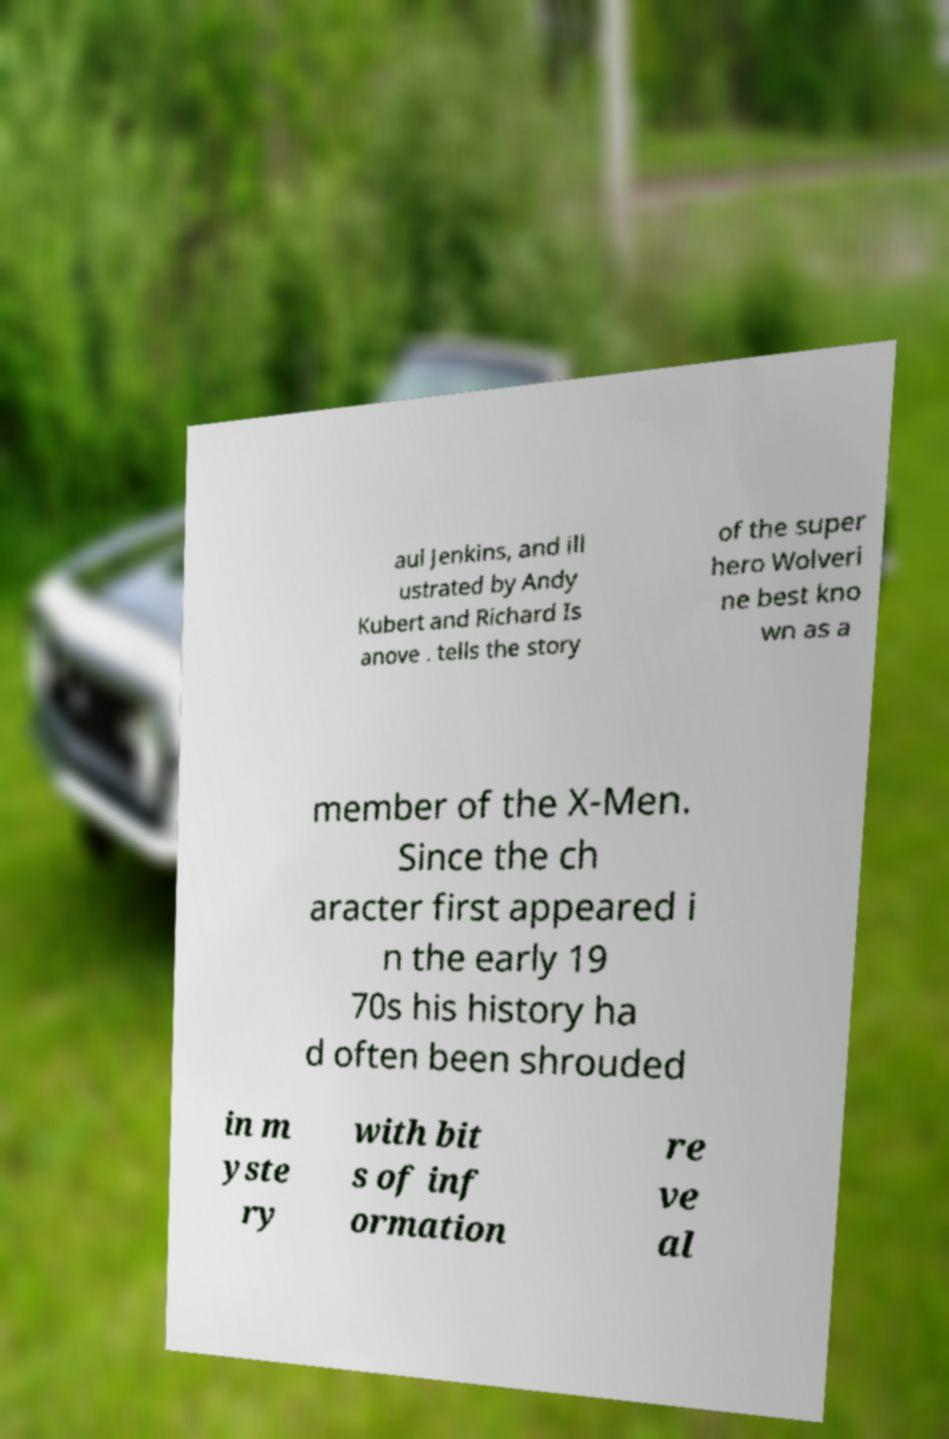There's text embedded in this image that I need extracted. Can you transcribe it verbatim? aul Jenkins, and ill ustrated by Andy Kubert and Richard Is anove . tells the story of the super hero Wolveri ne best kno wn as a member of the X-Men. Since the ch aracter first appeared i n the early 19 70s his history ha d often been shrouded in m yste ry with bit s of inf ormation re ve al 